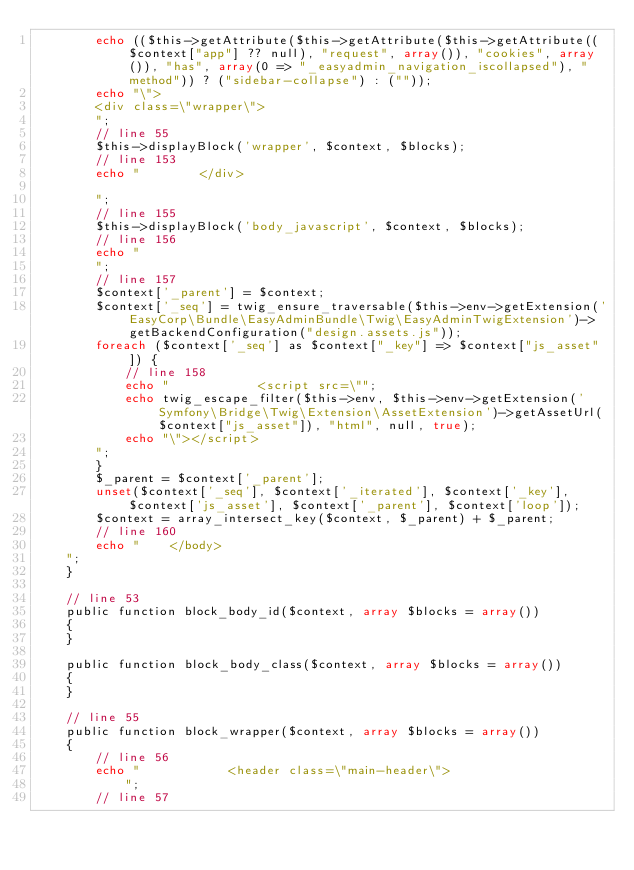<code> <loc_0><loc_0><loc_500><loc_500><_PHP_>        echo (($this->getAttribute($this->getAttribute($this->getAttribute(($context["app"] ?? null), "request", array()), "cookies", array()), "has", array(0 => "_easyadmin_navigation_iscollapsed"), "method")) ? ("sidebar-collapse") : (""));
        echo "\">
        <div class=\"wrapper\">
        ";
        // line 55
        $this->displayBlock('wrapper', $context, $blocks);
        // line 153
        echo "        </div>

        ";
        // line 155
        $this->displayBlock('body_javascript', $context, $blocks);
        // line 156
        echo "
        ";
        // line 157
        $context['_parent'] = $context;
        $context['_seq'] = twig_ensure_traversable($this->env->getExtension('EasyCorp\Bundle\EasyAdminBundle\Twig\EasyAdminTwigExtension')->getBackendConfiguration("design.assets.js"));
        foreach ($context['_seq'] as $context["_key"] => $context["js_asset"]) {
            // line 158
            echo "            <script src=\"";
            echo twig_escape_filter($this->env, $this->env->getExtension('Symfony\Bridge\Twig\Extension\AssetExtension')->getAssetUrl($context["js_asset"]), "html", null, true);
            echo "\"></script>
        ";
        }
        $_parent = $context['_parent'];
        unset($context['_seq'], $context['_iterated'], $context['_key'], $context['js_asset'], $context['_parent'], $context['loop']);
        $context = array_intersect_key($context, $_parent) + $_parent;
        // line 160
        echo "    </body>
    ";
    }

    // line 53
    public function block_body_id($context, array $blocks = array())
    {
    }

    public function block_body_class($context, array $blocks = array())
    {
    }

    // line 55
    public function block_wrapper($context, array $blocks = array())
    {
        // line 56
        echo "            <header class=\"main-header\">
            ";
        // line 57</code> 